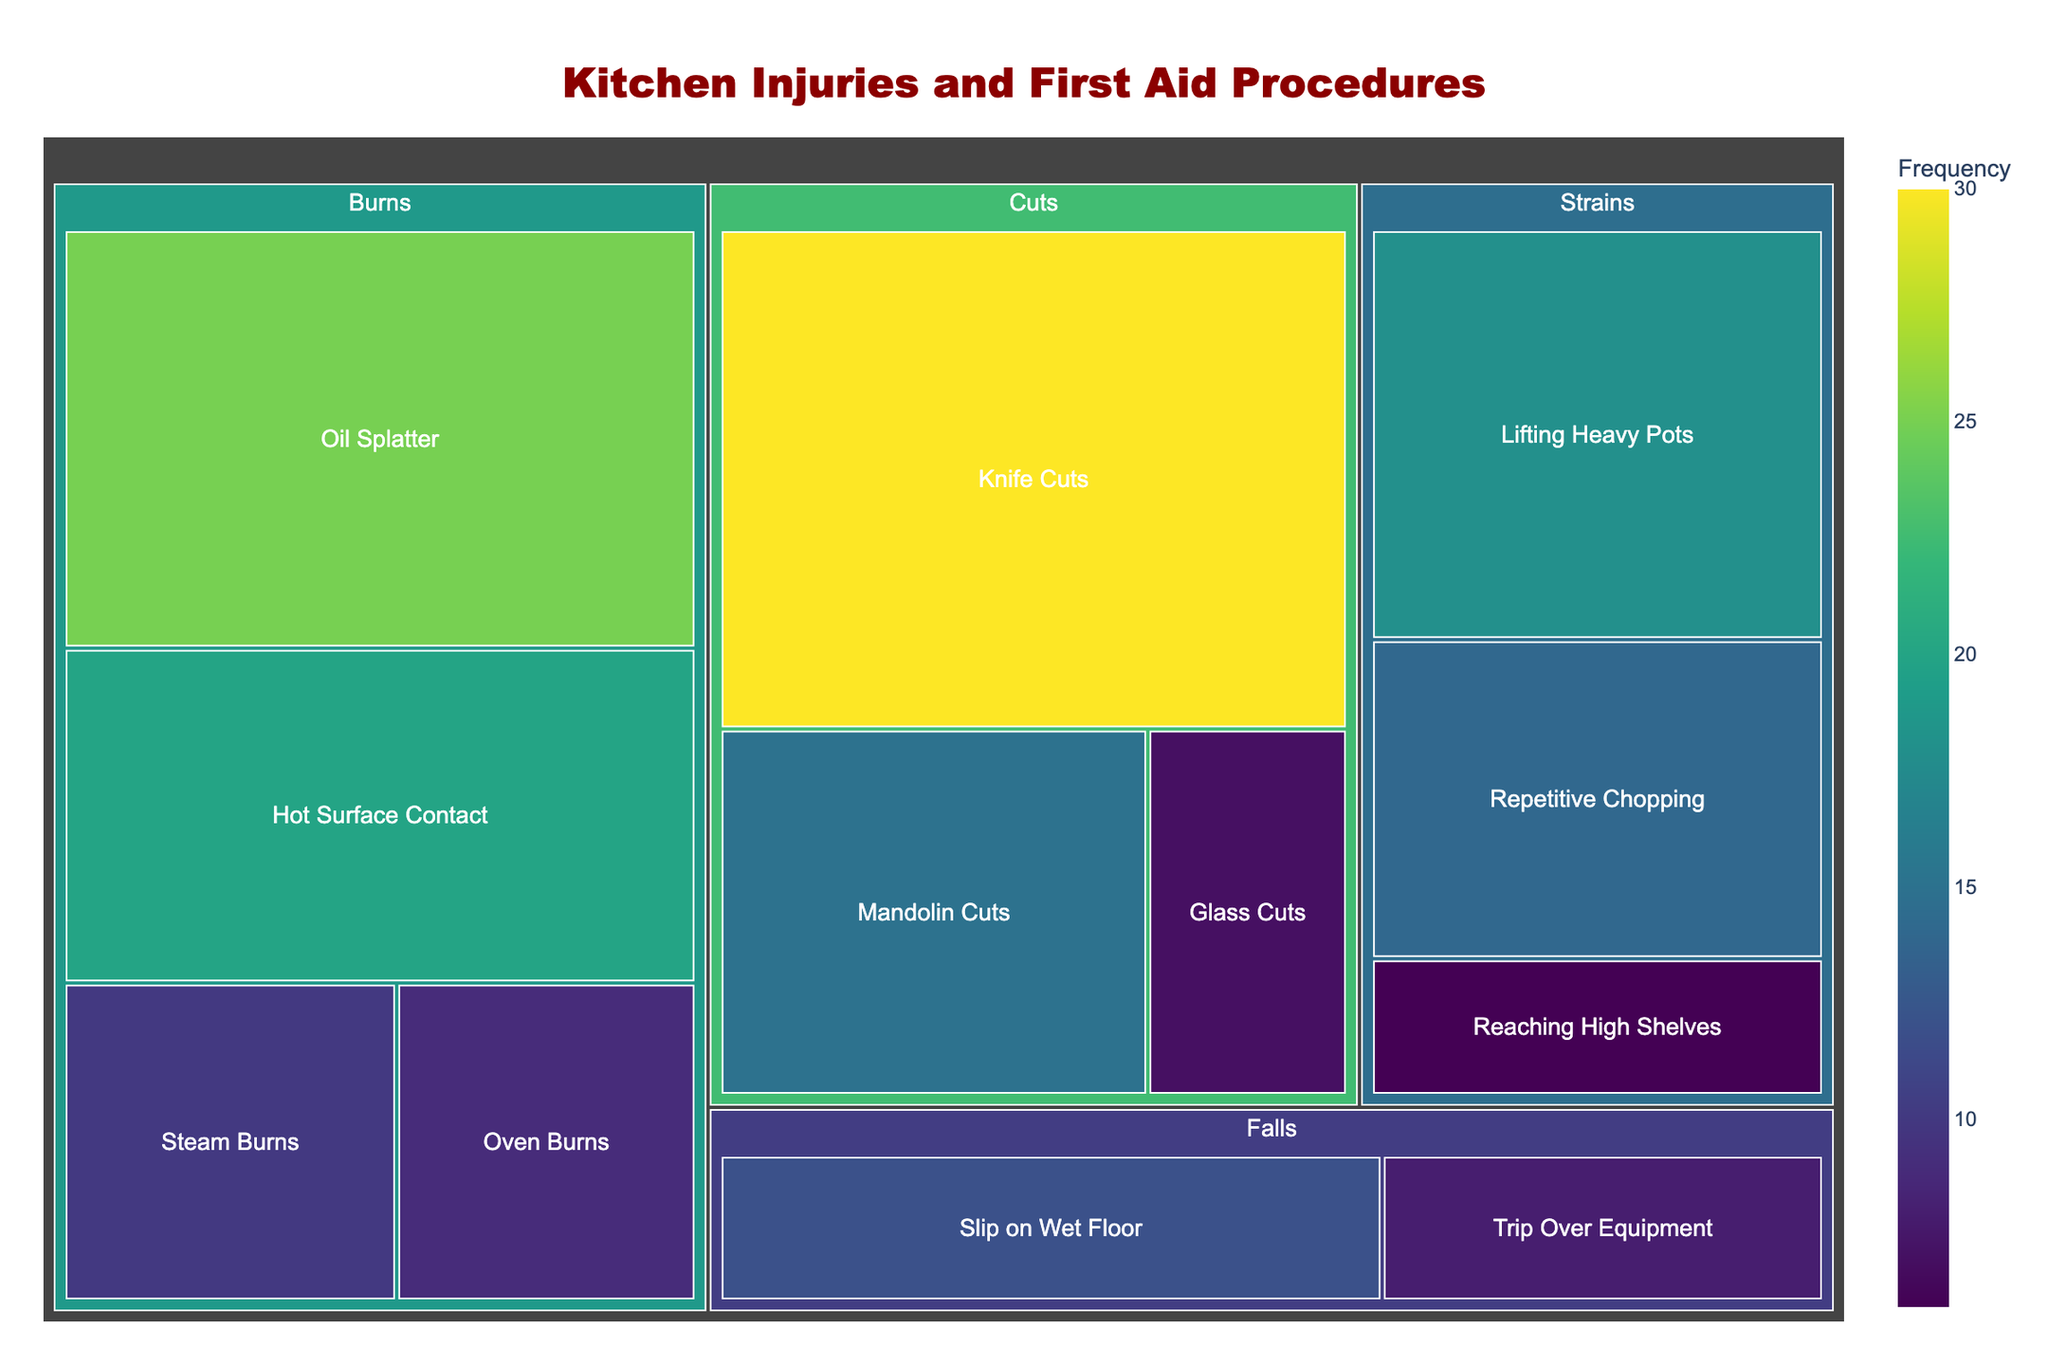What is the most common type of injury in the kitchen? Look at the Treemap and find the category with the largest segment. The segment for "Knife Cuts" under the "Cuts" category is the largest.
Answer: Knife Cuts Which injury type has the lowest frequency among burns? Identify all burn injury types and compare their frequencies. "Steam Burns" has the lowest frequency among burns.
Answer: Steam Burns How many types of injuries are due to falls? Check the Treemap for categories related to falls and count the types within that category. The types "Slip on Wet Floor" and "Trip Over Equipment" are the two types related to falls.
Answer: 2 What is the first aid procedure for mandolin cuts? Find "Mandolin Cuts" in the Treemap and read its associated first aid procedure.
Answer: Clean wound and apply sterile dressing What is the total frequency of injuries due to burns? Add the frequencies of all types of burn injuries: Oil Splatter (25), Hot Surface Contact (20), Steam Burns (10), and Oven Burns (9). The total is 25 + 20 + 10 + 9 = 64.
Answer: 64 Which injury category requires applying ice as a common first aid procedure? Look through the Treemap for procedures mentioning ice. Both injury types under the "Falls" category mention using ice.
Answer: Falls Which category has the smallest total frequency of injuries, and what is that total? Compare the total frequencies of each category: add the frequencies within each category and find the smallest sum. "Falls" has 12 + 8 = 20, which is the smallest total.
Answer: Falls, 20 Which type of strain injury requires providing wrist support? Find "Repetitive Chopping" in the Treemap and its first aid procedure includes providing wrist support.
Answer: Repetitive Chopping What is the combined frequency of cuts excluding "Knife Cuts"? Add the frequencies of all the cut injuries except "Knife Cuts": Mandolin Cuts (15) + Glass Cuts (7) = 22.
Answer: 22 How does the frequency of knife cuts compare to oil splatter burns? Compare the frequencies directly. Knife Cuts have a frequency of 30, whereas Oil Splatter has a frequency of 25.
Answer: Knife Cuts is higher than Oil Splatter 